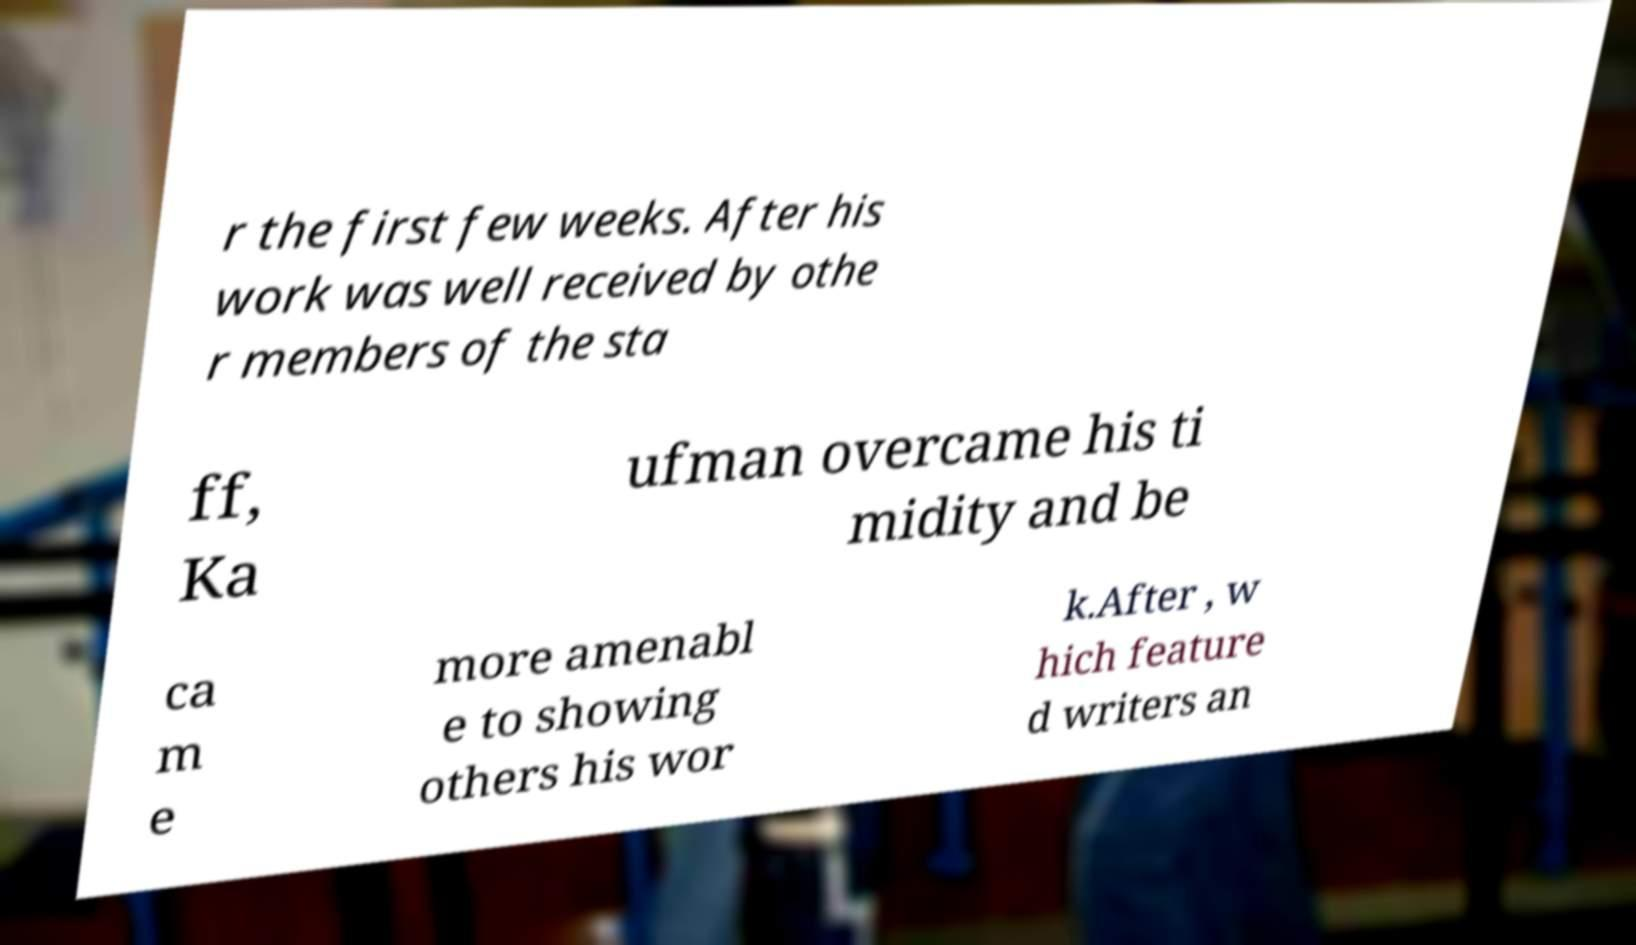I need the written content from this picture converted into text. Can you do that? r the first few weeks. After his work was well received by othe r members of the sta ff, Ka ufman overcame his ti midity and be ca m e more amenabl e to showing others his wor k.After , w hich feature d writers an 